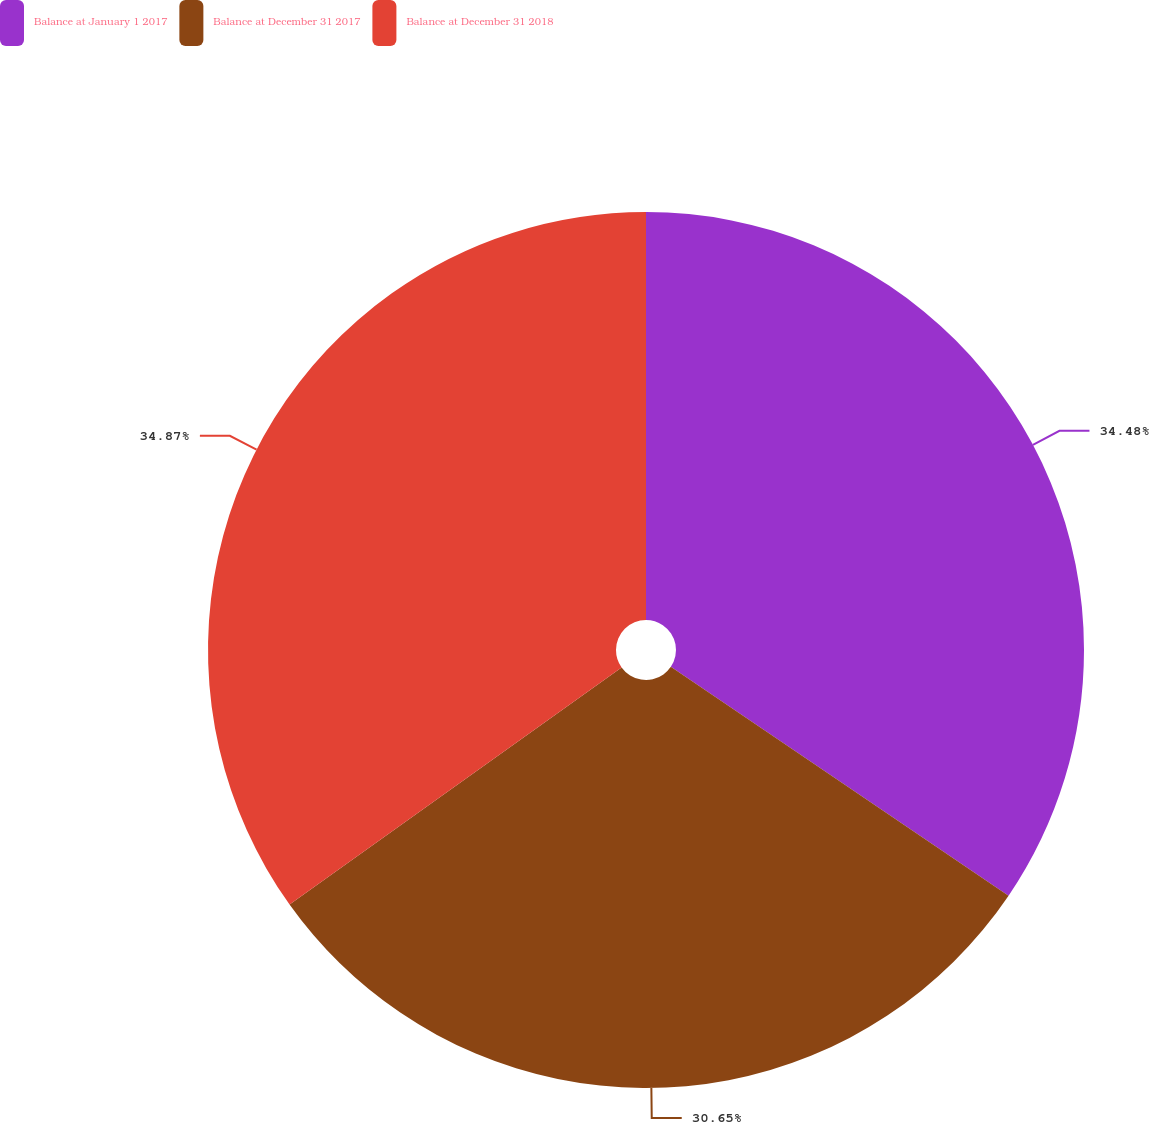<chart> <loc_0><loc_0><loc_500><loc_500><pie_chart><fcel>Balance at January 1 2017<fcel>Balance at December 31 2017<fcel>Balance at December 31 2018<nl><fcel>34.48%<fcel>30.65%<fcel>34.87%<nl></chart> 